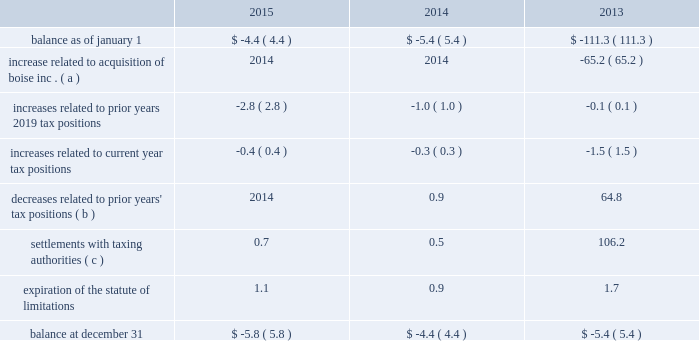Cash payments for federal , state , and foreign income taxes were $ 238.3 million , $ 189.5 million , and $ 90.7 million for the years ended december 31 , 2015 , 2014 , and 2013 , respectively .
The table summarizes the changes related to pca 2019s gross unrecognized tax benefits excluding interest and penalties ( dollars in millions ) : .
( a ) in 2013 , pca acquired $ 65.2 million of gross unrecognized tax benefits from boise inc .
That related primarily to the taxability of the alternative energy tax credits .
( b ) the 2013 amount includes a $ 64.3 million gross decrease related to the taxability of the alternative energy tax credits claimed in 2009 excise tax returns by boise inc .
For further discussion regarding these credits , see note 7 , alternative energy tax credits .
( c ) the 2013 amount includes a $ 104.7 million gross decrease related to the conclusion of the internal revenue service audit of pca 2019s alternative energy tax credits .
For further discussion regarding these credits , see note 7 , alternative energy tax credits .
At december 31 , 2015 , pca had recorded a $ 5.8 million gross reserve for unrecognized tax benefits , excluding interest and penalties .
Of the total , $ 4.2 million ( net of the federal benefit for state taxes ) would impact the effective tax rate if recognized .
Pca recognizes interest accrued related to unrecognized tax benefits and penalties as income tax expense .
At december 31 , 2015 and 2014 , we had an insignificant amount of interest and penalties recorded for unrecognized tax benefits included in the table above .
Pca does not expect the unrecognized tax benefits to change significantly over the next 12 months .
Pca is subject to taxation in the united states and various state and foreign jurisdictions .
A federal examination of the tax years 2010 2014 2012 was concluded in february 2015 .
A federal examination of the 2013 tax year began in october 2015 .
The tax years 2014 2014 2015 remain open to federal examination .
The tax years 2011 2014 2015 remain open to state examinations .
Some foreign tax jurisdictions are open to examination for the 2008 tax year forward .
Through the boise acquisition , pca recorded net operating losses and credit carryforwards from 2008 through 2011 and 2013 that are subject to examinations and adjustments for at least three years following the year in which utilized .
Alternative energy tax credits the company generates black liquor as a by-product of its pulp manufacturing process , which entitled it to certain federal income tax credits .
When black liquor is mixed with diesel , it is considered an alternative fuel that was eligible for a $ 0.50 per gallon refundable alternative energy tax credit for gallons produced before december 31 , 2009 .
Black liquor was also eligible for a $ 1.01 per gallon taxable cellulosic biofuel producer credit for gallons of black liquor produced and used in 2009 .
In 2013 , we reversed $ 166.0 million of a reserve for unrecognized tax benefits for alternative energy tax credits as a benefit to income taxes .
Approximately $ 103.9 million ( $ 102.0 million of tax , net of the federal benefit for state taxes , plus $ 1.9 million of accrued interest ) of the reversal is due to the completion of the irs .
How many federal examinations were concluded in february 2015? 
Computations: (2012 - 2010)
Answer: 2.0. Cash payments for federal , state , and foreign income taxes were $ 238.3 million , $ 189.5 million , and $ 90.7 million for the years ended december 31 , 2015 , 2014 , and 2013 , respectively .
The table summarizes the changes related to pca 2019s gross unrecognized tax benefits excluding interest and penalties ( dollars in millions ) : .
( a ) in 2013 , pca acquired $ 65.2 million of gross unrecognized tax benefits from boise inc .
That related primarily to the taxability of the alternative energy tax credits .
( b ) the 2013 amount includes a $ 64.3 million gross decrease related to the taxability of the alternative energy tax credits claimed in 2009 excise tax returns by boise inc .
For further discussion regarding these credits , see note 7 , alternative energy tax credits .
( c ) the 2013 amount includes a $ 104.7 million gross decrease related to the conclusion of the internal revenue service audit of pca 2019s alternative energy tax credits .
For further discussion regarding these credits , see note 7 , alternative energy tax credits .
At december 31 , 2015 , pca had recorded a $ 5.8 million gross reserve for unrecognized tax benefits , excluding interest and penalties .
Of the total , $ 4.2 million ( net of the federal benefit for state taxes ) would impact the effective tax rate if recognized .
Pca recognizes interest accrued related to unrecognized tax benefits and penalties as income tax expense .
At december 31 , 2015 and 2014 , we had an insignificant amount of interest and penalties recorded for unrecognized tax benefits included in the table above .
Pca does not expect the unrecognized tax benefits to change significantly over the next 12 months .
Pca is subject to taxation in the united states and various state and foreign jurisdictions .
A federal examination of the tax years 2010 2014 2012 was concluded in february 2015 .
A federal examination of the 2013 tax year began in october 2015 .
The tax years 2014 2014 2015 remain open to federal examination .
The tax years 2011 2014 2015 remain open to state examinations .
Some foreign tax jurisdictions are open to examination for the 2008 tax year forward .
Through the boise acquisition , pca recorded net operating losses and credit carryforwards from 2008 through 2011 and 2013 that are subject to examinations and adjustments for at least three years following the year in which utilized .
Alternative energy tax credits the company generates black liquor as a by-product of its pulp manufacturing process , which entitled it to certain federal income tax credits .
When black liquor is mixed with diesel , it is considered an alternative fuel that was eligible for a $ 0.50 per gallon refundable alternative energy tax credit for gallons produced before december 31 , 2009 .
Black liquor was also eligible for a $ 1.01 per gallon taxable cellulosic biofuel producer credit for gallons of black liquor produced and used in 2009 .
In 2013 , we reversed $ 166.0 million of a reserve for unrecognized tax benefits for alternative energy tax credits as a benefit to income taxes .
Approximately $ 103.9 million ( $ 102.0 million of tax , net of the federal benefit for state taxes , plus $ 1.9 million of accrued interest ) of the reversal is due to the completion of the irs .
What was the difference in millions of cash payments for federal , state , and foreign income taxes between 2013 and 2014? 
Computations: (189.5 - 90.7)
Answer: 98.8. 